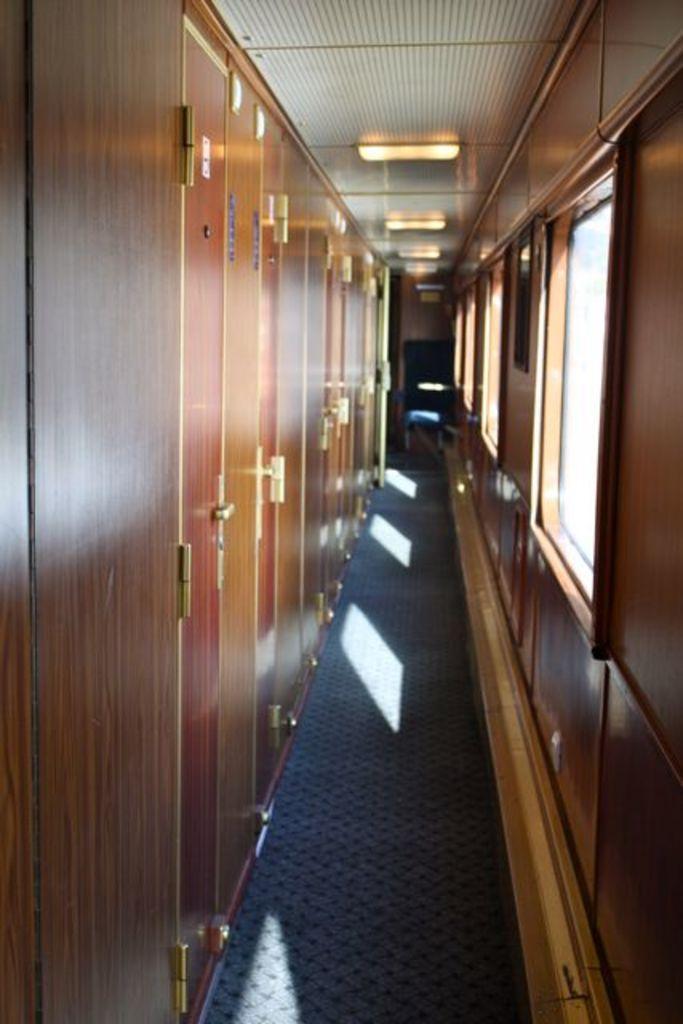Could you give a brief overview of what you see in this image? In the picture I can see the wooden doors with handle arrangement. There is a lighting arrangement on the roof. These are looking like photo frames on the wall on the right side. It is looking like a carpet on the floor. 